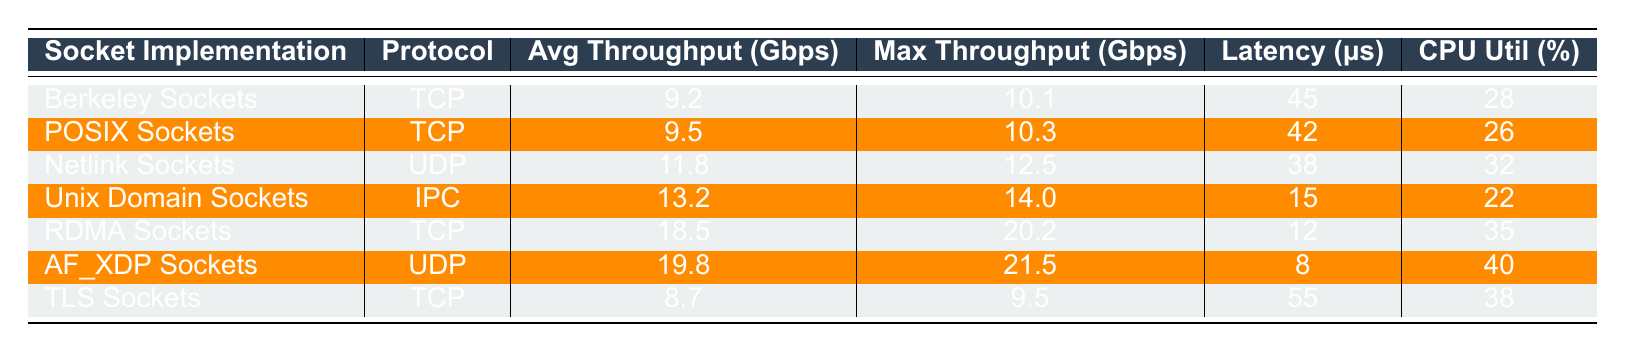What is the average throughput of UNIX Domain Sockets? The average throughput for UNIX Domain Sockets, according to the table, is listed as 13.2 Gbps.
Answer: 13.2 Gbps Which socket implementation has the lowest CPU utilization? Based on the table, UNIX Domain Sockets have the lowest CPU utilization at 22%.
Answer: 22% What is the maximum throughput of AF_XDP Sockets? The maximum throughput for AF_XDP Sockets is indicated to be 21.5 Gbps in the table.
Answer: 21.5 Gbps How much higher is the average throughput of RDMA Sockets compared to Berkeley Sockets? The average throughput for RDMA Sockets is 18.5 Gbps and for Berkeley Sockets is 9.2 Gbps. The difference is 18.5 - 9.2 = 9.3 Gbps.
Answer: 9.3 Gbps What is the latency of TLS Sockets? The table shows that the latency for TLS Sockets is 55 μs.
Answer: 55 μs Is it true that Netlink Sockets have a higher average throughput than POSIX Sockets? The table lists the average throughput of Netlink Sockets at 11.8 Gbps and POSIX Sockets at 9.5 Gbps, confirming that Netlink Sockets do have a higher throughput.
Answer: Yes Which socket implementation shows the highest average throughput and what is that value? The table indicates that AF_XDP Sockets have the highest average throughput at 19.8 Gbps.
Answer: 19.8 Gbps What is the difference in latency between RDMA Sockets and Unix Domain Sockets? RDMA Sockets have a latency of 12 μs and Unix Domain Sockets have a latency of 15 μs. The difference is 15 - 12 = 3 μs.
Answer: 3 μs Considering all implementations, which protocol has the lowest maximum throughput, and what is it? According to the table, TLS Sockets, which use TCP, have the lowest maximum throughput at 9.5 Gbps.
Answer: 9.5 Gbps If we average the CPU utilization of all the sockets, what would that be? The CPU utilization values are 28, 26, 32, 22, 35, 40, and 38. Adding these gives 28 + 26 + 32 + 22 + 35 + 40 + 38 = 221, and dividing by 7 gives approximately 31.57%.
Answer: 31.57% 